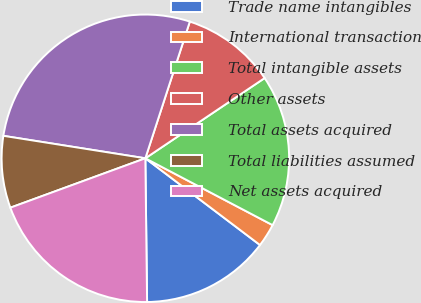<chart> <loc_0><loc_0><loc_500><loc_500><pie_chart><fcel>Trade name intangibles<fcel>International transaction<fcel>Total intangible assets<fcel>Other assets<fcel>Total assets acquired<fcel>Total liabilities assumed<fcel>Net assets acquired<nl><fcel>14.5%<fcel>2.61%<fcel>17.12%<fcel>10.57%<fcel>27.51%<fcel>8.08%<fcel>19.61%<nl></chart> 